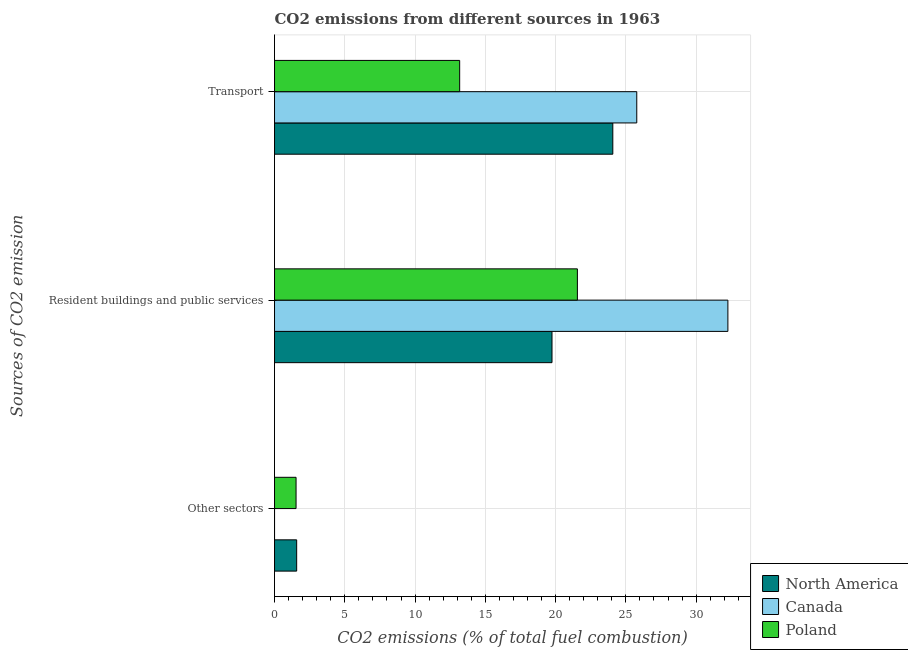How many different coloured bars are there?
Ensure brevity in your answer.  3. Are the number of bars per tick equal to the number of legend labels?
Your answer should be very brief. No. Are the number of bars on each tick of the Y-axis equal?
Your response must be concise. No. What is the label of the 2nd group of bars from the top?
Ensure brevity in your answer.  Resident buildings and public services. What is the percentage of co2 emissions from resident buildings and public services in Canada?
Offer a very short reply. 32.26. Across all countries, what is the maximum percentage of co2 emissions from other sectors?
Your response must be concise. 1.58. In which country was the percentage of co2 emissions from resident buildings and public services maximum?
Provide a short and direct response. Canada. What is the total percentage of co2 emissions from transport in the graph?
Keep it short and to the point. 63.02. What is the difference between the percentage of co2 emissions from transport in Poland and that in North America?
Provide a succinct answer. -10.9. What is the difference between the percentage of co2 emissions from other sectors in North America and the percentage of co2 emissions from resident buildings and public services in Poland?
Give a very brief answer. -19.98. What is the average percentage of co2 emissions from resident buildings and public services per country?
Your answer should be compact. 24.52. What is the difference between the percentage of co2 emissions from other sectors and percentage of co2 emissions from transport in North America?
Provide a succinct answer. -22.5. In how many countries, is the percentage of co2 emissions from transport greater than 11 %?
Provide a succinct answer. 3. What is the ratio of the percentage of co2 emissions from resident buildings and public services in North America to that in Poland?
Give a very brief answer. 0.92. Is the percentage of co2 emissions from transport in North America less than that in Poland?
Keep it short and to the point. No. Is the difference between the percentage of co2 emissions from resident buildings and public services in Canada and Poland greater than the difference between the percentage of co2 emissions from transport in Canada and Poland?
Provide a succinct answer. No. What is the difference between the highest and the second highest percentage of co2 emissions from resident buildings and public services?
Provide a short and direct response. 10.71. What is the difference between the highest and the lowest percentage of co2 emissions from transport?
Provide a succinct answer. 12.6. Is the sum of the percentage of co2 emissions from other sectors in Poland and North America greater than the maximum percentage of co2 emissions from transport across all countries?
Offer a very short reply. No. How many bars are there?
Your answer should be very brief. 8. How many countries are there in the graph?
Your answer should be compact. 3. Does the graph contain grids?
Give a very brief answer. Yes. Where does the legend appear in the graph?
Your answer should be compact. Bottom right. How are the legend labels stacked?
Make the answer very short. Vertical. What is the title of the graph?
Provide a succinct answer. CO2 emissions from different sources in 1963. What is the label or title of the X-axis?
Your answer should be compact. CO2 emissions (% of total fuel combustion). What is the label or title of the Y-axis?
Keep it short and to the point. Sources of CO2 emission. What is the CO2 emissions (% of total fuel combustion) of North America in Other sectors?
Provide a succinct answer. 1.58. What is the CO2 emissions (% of total fuel combustion) of Poland in Other sectors?
Provide a succinct answer. 1.53. What is the CO2 emissions (% of total fuel combustion) in North America in Resident buildings and public services?
Give a very brief answer. 19.74. What is the CO2 emissions (% of total fuel combustion) of Canada in Resident buildings and public services?
Ensure brevity in your answer.  32.26. What is the CO2 emissions (% of total fuel combustion) of Poland in Resident buildings and public services?
Your answer should be compact. 21.55. What is the CO2 emissions (% of total fuel combustion) in North America in Transport?
Offer a terse response. 24.07. What is the CO2 emissions (% of total fuel combustion) of Canada in Transport?
Make the answer very short. 25.78. What is the CO2 emissions (% of total fuel combustion) of Poland in Transport?
Ensure brevity in your answer.  13.17. Across all Sources of CO2 emission, what is the maximum CO2 emissions (% of total fuel combustion) of North America?
Keep it short and to the point. 24.07. Across all Sources of CO2 emission, what is the maximum CO2 emissions (% of total fuel combustion) in Canada?
Give a very brief answer. 32.26. Across all Sources of CO2 emission, what is the maximum CO2 emissions (% of total fuel combustion) in Poland?
Keep it short and to the point. 21.55. Across all Sources of CO2 emission, what is the minimum CO2 emissions (% of total fuel combustion) in North America?
Provide a short and direct response. 1.58. Across all Sources of CO2 emission, what is the minimum CO2 emissions (% of total fuel combustion) in Canada?
Give a very brief answer. 0. Across all Sources of CO2 emission, what is the minimum CO2 emissions (% of total fuel combustion) in Poland?
Your answer should be compact. 1.53. What is the total CO2 emissions (% of total fuel combustion) of North America in the graph?
Provide a succinct answer. 45.39. What is the total CO2 emissions (% of total fuel combustion) of Canada in the graph?
Offer a terse response. 58.04. What is the total CO2 emissions (% of total fuel combustion) of Poland in the graph?
Your answer should be compact. 36.26. What is the difference between the CO2 emissions (% of total fuel combustion) of North America in Other sectors and that in Resident buildings and public services?
Your response must be concise. -18.17. What is the difference between the CO2 emissions (% of total fuel combustion) in Poland in Other sectors and that in Resident buildings and public services?
Offer a terse response. -20.02. What is the difference between the CO2 emissions (% of total fuel combustion) of North America in Other sectors and that in Transport?
Provide a succinct answer. -22.5. What is the difference between the CO2 emissions (% of total fuel combustion) of Poland in Other sectors and that in Transport?
Your response must be concise. -11.64. What is the difference between the CO2 emissions (% of total fuel combustion) of North America in Resident buildings and public services and that in Transport?
Your answer should be compact. -4.33. What is the difference between the CO2 emissions (% of total fuel combustion) in Canada in Resident buildings and public services and that in Transport?
Your response must be concise. 6.48. What is the difference between the CO2 emissions (% of total fuel combustion) of Poland in Resident buildings and public services and that in Transport?
Offer a very short reply. 8.38. What is the difference between the CO2 emissions (% of total fuel combustion) in North America in Other sectors and the CO2 emissions (% of total fuel combustion) in Canada in Resident buildings and public services?
Your answer should be compact. -30.68. What is the difference between the CO2 emissions (% of total fuel combustion) of North America in Other sectors and the CO2 emissions (% of total fuel combustion) of Poland in Resident buildings and public services?
Make the answer very short. -19.98. What is the difference between the CO2 emissions (% of total fuel combustion) in North America in Other sectors and the CO2 emissions (% of total fuel combustion) in Canada in Transport?
Your answer should be very brief. -24.2. What is the difference between the CO2 emissions (% of total fuel combustion) in North America in Other sectors and the CO2 emissions (% of total fuel combustion) in Poland in Transport?
Give a very brief answer. -11.6. What is the difference between the CO2 emissions (% of total fuel combustion) of North America in Resident buildings and public services and the CO2 emissions (% of total fuel combustion) of Canada in Transport?
Provide a succinct answer. -6.03. What is the difference between the CO2 emissions (% of total fuel combustion) of North America in Resident buildings and public services and the CO2 emissions (% of total fuel combustion) of Poland in Transport?
Your answer should be compact. 6.57. What is the difference between the CO2 emissions (% of total fuel combustion) in Canada in Resident buildings and public services and the CO2 emissions (% of total fuel combustion) in Poland in Transport?
Offer a very short reply. 19.09. What is the average CO2 emissions (% of total fuel combustion) of North America per Sources of CO2 emission?
Provide a succinct answer. 15.13. What is the average CO2 emissions (% of total fuel combustion) of Canada per Sources of CO2 emission?
Offer a terse response. 19.35. What is the average CO2 emissions (% of total fuel combustion) in Poland per Sources of CO2 emission?
Your answer should be compact. 12.09. What is the difference between the CO2 emissions (% of total fuel combustion) in North America and CO2 emissions (% of total fuel combustion) in Poland in Other sectors?
Your answer should be very brief. 0.04. What is the difference between the CO2 emissions (% of total fuel combustion) in North America and CO2 emissions (% of total fuel combustion) in Canada in Resident buildings and public services?
Your response must be concise. -12.52. What is the difference between the CO2 emissions (% of total fuel combustion) in North America and CO2 emissions (% of total fuel combustion) in Poland in Resident buildings and public services?
Offer a very short reply. -1.81. What is the difference between the CO2 emissions (% of total fuel combustion) in Canada and CO2 emissions (% of total fuel combustion) in Poland in Resident buildings and public services?
Offer a terse response. 10.71. What is the difference between the CO2 emissions (% of total fuel combustion) of North America and CO2 emissions (% of total fuel combustion) of Canada in Transport?
Your response must be concise. -1.7. What is the difference between the CO2 emissions (% of total fuel combustion) in North America and CO2 emissions (% of total fuel combustion) in Poland in Transport?
Offer a very short reply. 10.9. What is the difference between the CO2 emissions (% of total fuel combustion) in Canada and CO2 emissions (% of total fuel combustion) in Poland in Transport?
Your answer should be very brief. 12.6. What is the ratio of the CO2 emissions (% of total fuel combustion) of North America in Other sectors to that in Resident buildings and public services?
Offer a very short reply. 0.08. What is the ratio of the CO2 emissions (% of total fuel combustion) in Poland in Other sectors to that in Resident buildings and public services?
Your answer should be very brief. 0.07. What is the ratio of the CO2 emissions (% of total fuel combustion) in North America in Other sectors to that in Transport?
Offer a very short reply. 0.07. What is the ratio of the CO2 emissions (% of total fuel combustion) of Poland in Other sectors to that in Transport?
Your answer should be compact. 0.12. What is the ratio of the CO2 emissions (% of total fuel combustion) of North America in Resident buildings and public services to that in Transport?
Provide a succinct answer. 0.82. What is the ratio of the CO2 emissions (% of total fuel combustion) in Canada in Resident buildings and public services to that in Transport?
Your answer should be compact. 1.25. What is the ratio of the CO2 emissions (% of total fuel combustion) of Poland in Resident buildings and public services to that in Transport?
Offer a very short reply. 1.64. What is the difference between the highest and the second highest CO2 emissions (% of total fuel combustion) of North America?
Provide a succinct answer. 4.33. What is the difference between the highest and the second highest CO2 emissions (% of total fuel combustion) of Poland?
Offer a terse response. 8.38. What is the difference between the highest and the lowest CO2 emissions (% of total fuel combustion) in North America?
Your answer should be very brief. 22.5. What is the difference between the highest and the lowest CO2 emissions (% of total fuel combustion) in Canada?
Your answer should be very brief. 32.26. What is the difference between the highest and the lowest CO2 emissions (% of total fuel combustion) in Poland?
Ensure brevity in your answer.  20.02. 